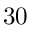<formula> <loc_0><loc_0><loc_500><loc_500>3 0</formula> 